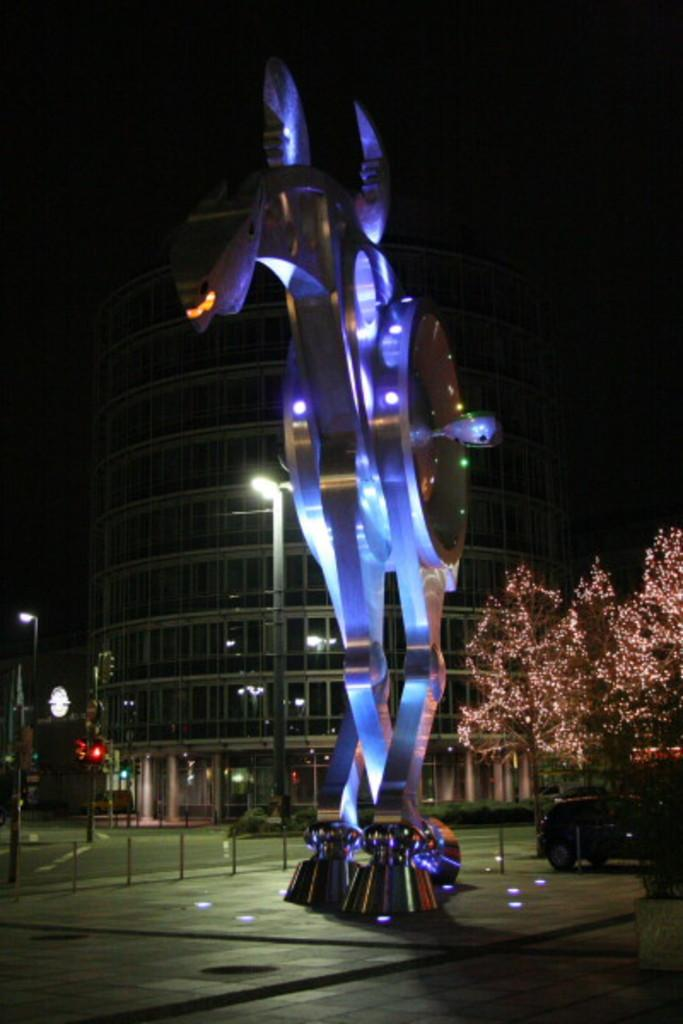What is the main subject of the image? There is a sculpture in the image. What can be seen in the background of the image? There is a building in the background of the image. Can you describe the lighting in the image? There is light in the image. What type of natural elements are present in the image? There are trees in the image. What type of transportation is visible in the image? Cars are visible on the road in the image. How would you describe the overall appearance of the image? The image appears to be dark. What type of lamp is hanging from the sculpture in the image? There is no lamp present in the image; it only features a sculpture, a building, trees, cars, light, and a dark appearance. 